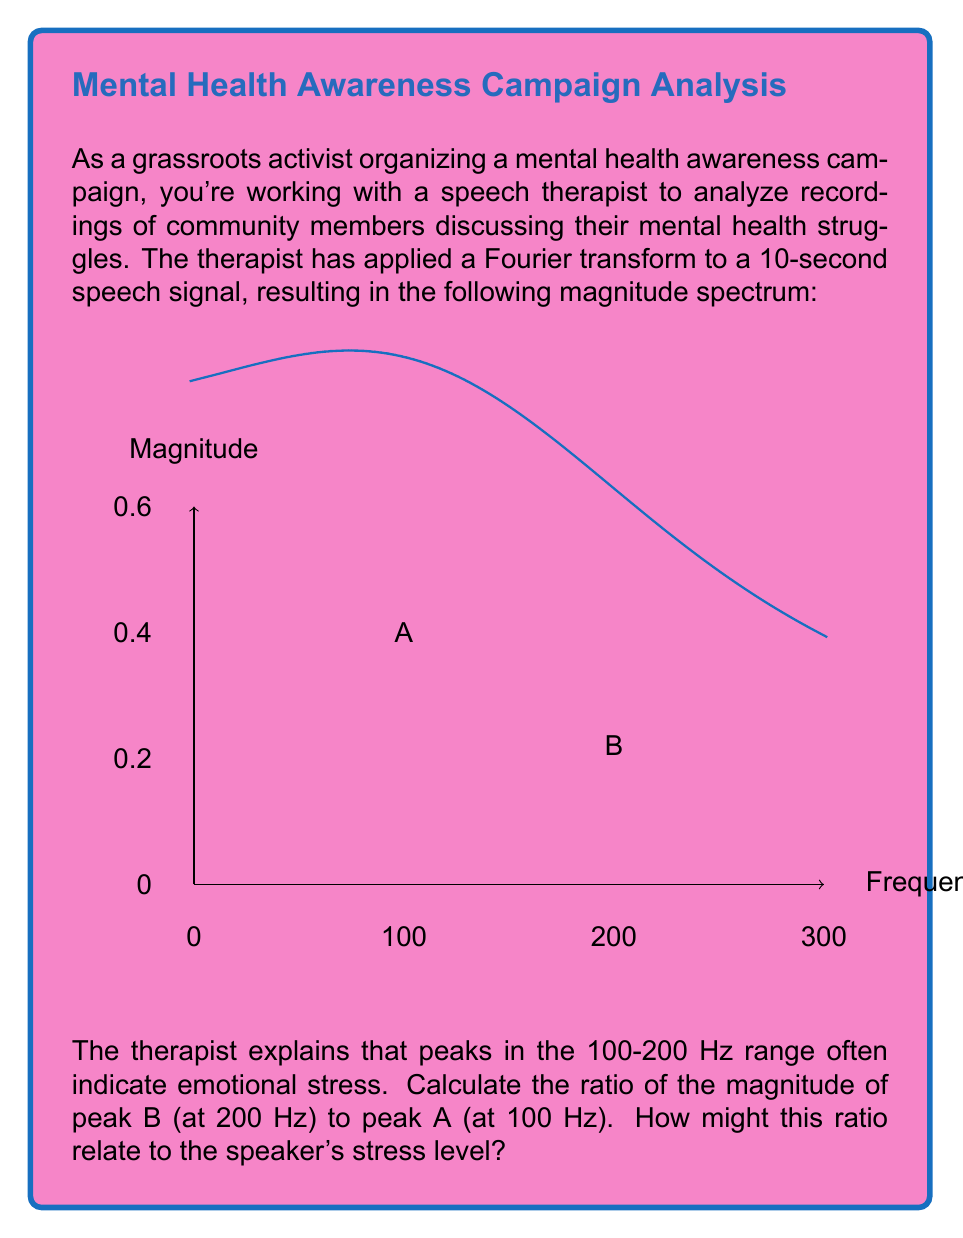Teach me how to tackle this problem. To solve this problem, we need to follow these steps:

1. Identify the magnitude values of peaks A and B from the graph:
   Peak A (100 Hz): Magnitude ≈ 0.38
   Peak B (200 Hz): Magnitude ≈ 0.22

2. Calculate the ratio of peak B to peak A:
   $$\text{Ratio} = \frac{\text{Magnitude of Peak B}}{\text{Magnitude of Peak A}} = \frac{0.22}{0.38}$$

3. Perform the division:
   $$\frac{0.22}{0.38} \approx 0.5789$$

4. Interpret the result:
   The ratio is approximately 0.5789, which means the magnitude of peak B is about 57.89% of peak A's magnitude.

5. Relate to stress level:
   A higher ratio (closer to 1) would indicate that the energy in the higher frequency (200 Hz) is closer to that of the lower frequency (100 Hz), which could suggest increased emotional stress. In this case, the ratio of 0.5789 indicates a moderate level of stress, as there is still significant energy in the higher frequency range, but it's not as prominent as the lower frequency peak.

This analysis provides a quantitative measure that could be used to compare stress levels across different speakers or to track changes in an individual's stress level over time.
Answer: 0.5789; moderate stress level 